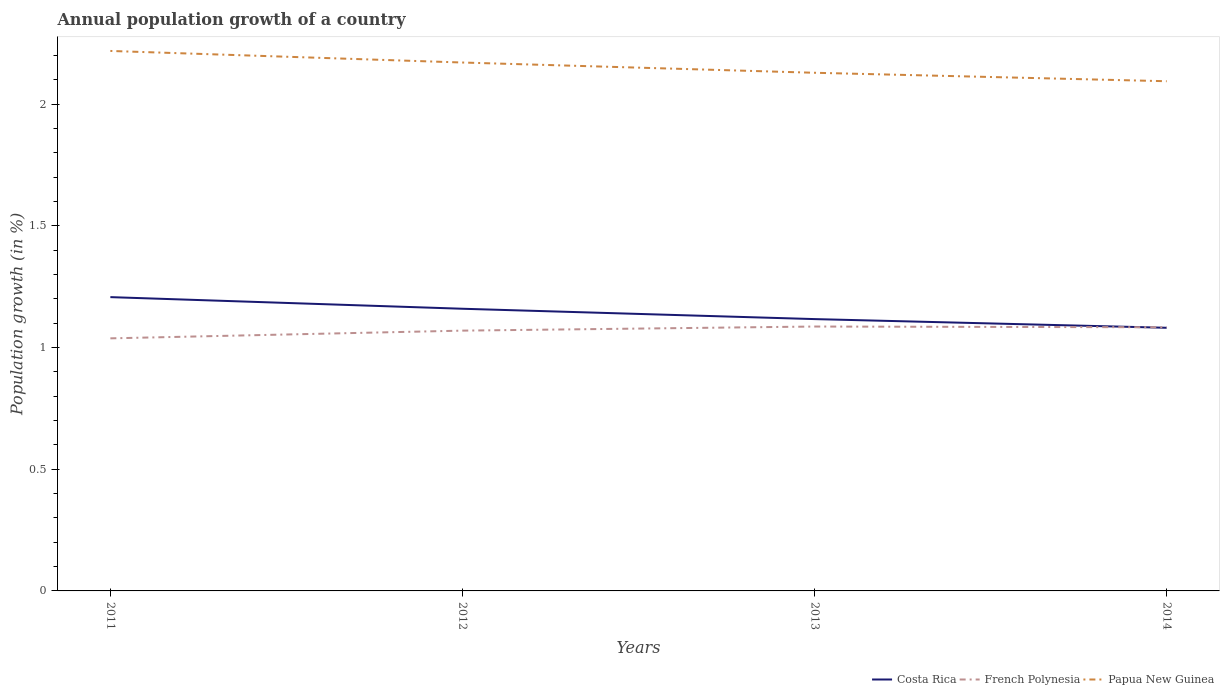Does the line corresponding to French Polynesia intersect with the line corresponding to Costa Rica?
Your answer should be very brief. Yes. Is the number of lines equal to the number of legend labels?
Offer a terse response. Yes. Across all years, what is the maximum annual population growth in Costa Rica?
Provide a short and direct response. 1.08. What is the total annual population growth in Costa Rica in the graph?
Make the answer very short. 0.05. What is the difference between the highest and the second highest annual population growth in Costa Rica?
Your answer should be very brief. 0.13. Is the annual population growth in Costa Rica strictly greater than the annual population growth in French Polynesia over the years?
Offer a terse response. No. How many years are there in the graph?
Your answer should be very brief. 4. Are the values on the major ticks of Y-axis written in scientific E-notation?
Your response must be concise. No. Does the graph contain grids?
Keep it short and to the point. No. Where does the legend appear in the graph?
Give a very brief answer. Bottom right. What is the title of the graph?
Offer a terse response. Annual population growth of a country. What is the label or title of the Y-axis?
Offer a terse response. Population growth (in %). What is the Population growth (in %) of Costa Rica in 2011?
Give a very brief answer. 1.21. What is the Population growth (in %) of French Polynesia in 2011?
Your answer should be very brief. 1.04. What is the Population growth (in %) in Papua New Guinea in 2011?
Offer a very short reply. 2.22. What is the Population growth (in %) of Costa Rica in 2012?
Provide a short and direct response. 1.16. What is the Population growth (in %) of French Polynesia in 2012?
Your answer should be compact. 1.07. What is the Population growth (in %) in Papua New Guinea in 2012?
Your response must be concise. 2.17. What is the Population growth (in %) in Costa Rica in 2013?
Your answer should be compact. 1.12. What is the Population growth (in %) of French Polynesia in 2013?
Ensure brevity in your answer.  1.09. What is the Population growth (in %) in Papua New Guinea in 2013?
Your answer should be very brief. 2.13. What is the Population growth (in %) in Costa Rica in 2014?
Your response must be concise. 1.08. What is the Population growth (in %) in French Polynesia in 2014?
Your response must be concise. 1.08. What is the Population growth (in %) of Papua New Guinea in 2014?
Provide a short and direct response. 2.09. Across all years, what is the maximum Population growth (in %) in Costa Rica?
Offer a terse response. 1.21. Across all years, what is the maximum Population growth (in %) in French Polynesia?
Your answer should be compact. 1.09. Across all years, what is the maximum Population growth (in %) of Papua New Guinea?
Your response must be concise. 2.22. Across all years, what is the minimum Population growth (in %) in Costa Rica?
Offer a very short reply. 1.08. Across all years, what is the minimum Population growth (in %) of French Polynesia?
Offer a very short reply. 1.04. Across all years, what is the minimum Population growth (in %) in Papua New Guinea?
Your response must be concise. 2.09. What is the total Population growth (in %) in Costa Rica in the graph?
Your response must be concise. 4.57. What is the total Population growth (in %) of French Polynesia in the graph?
Provide a short and direct response. 4.28. What is the total Population growth (in %) of Papua New Guinea in the graph?
Offer a terse response. 8.61. What is the difference between the Population growth (in %) of Costa Rica in 2011 and that in 2012?
Provide a short and direct response. 0.05. What is the difference between the Population growth (in %) in French Polynesia in 2011 and that in 2012?
Your answer should be compact. -0.03. What is the difference between the Population growth (in %) of Papua New Guinea in 2011 and that in 2012?
Give a very brief answer. 0.05. What is the difference between the Population growth (in %) of Costa Rica in 2011 and that in 2013?
Provide a succinct answer. 0.09. What is the difference between the Population growth (in %) in French Polynesia in 2011 and that in 2013?
Provide a succinct answer. -0.05. What is the difference between the Population growth (in %) in Papua New Guinea in 2011 and that in 2013?
Provide a succinct answer. 0.09. What is the difference between the Population growth (in %) of Costa Rica in 2011 and that in 2014?
Your response must be concise. 0.13. What is the difference between the Population growth (in %) of French Polynesia in 2011 and that in 2014?
Your answer should be very brief. -0.05. What is the difference between the Population growth (in %) in Papua New Guinea in 2011 and that in 2014?
Your answer should be compact. 0.12. What is the difference between the Population growth (in %) of Costa Rica in 2012 and that in 2013?
Offer a terse response. 0.04. What is the difference between the Population growth (in %) in French Polynesia in 2012 and that in 2013?
Your response must be concise. -0.02. What is the difference between the Population growth (in %) in Papua New Guinea in 2012 and that in 2013?
Ensure brevity in your answer.  0.04. What is the difference between the Population growth (in %) of Costa Rica in 2012 and that in 2014?
Your answer should be compact. 0.08. What is the difference between the Population growth (in %) in French Polynesia in 2012 and that in 2014?
Make the answer very short. -0.01. What is the difference between the Population growth (in %) in Papua New Guinea in 2012 and that in 2014?
Provide a succinct answer. 0.08. What is the difference between the Population growth (in %) of Costa Rica in 2013 and that in 2014?
Your answer should be compact. 0.04. What is the difference between the Population growth (in %) of French Polynesia in 2013 and that in 2014?
Your answer should be compact. 0. What is the difference between the Population growth (in %) of Papua New Guinea in 2013 and that in 2014?
Make the answer very short. 0.03. What is the difference between the Population growth (in %) of Costa Rica in 2011 and the Population growth (in %) of French Polynesia in 2012?
Give a very brief answer. 0.14. What is the difference between the Population growth (in %) in Costa Rica in 2011 and the Population growth (in %) in Papua New Guinea in 2012?
Your answer should be very brief. -0.96. What is the difference between the Population growth (in %) of French Polynesia in 2011 and the Population growth (in %) of Papua New Guinea in 2012?
Your response must be concise. -1.13. What is the difference between the Population growth (in %) in Costa Rica in 2011 and the Population growth (in %) in French Polynesia in 2013?
Offer a very short reply. 0.12. What is the difference between the Population growth (in %) of Costa Rica in 2011 and the Population growth (in %) of Papua New Guinea in 2013?
Your response must be concise. -0.92. What is the difference between the Population growth (in %) of French Polynesia in 2011 and the Population growth (in %) of Papua New Guinea in 2013?
Ensure brevity in your answer.  -1.09. What is the difference between the Population growth (in %) of Costa Rica in 2011 and the Population growth (in %) of French Polynesia in 2014?
Offer a terse response. 0.12. What is the difference between the Population growth (in %) in Costa Rica in 2011 and the Population growth (in %) in Papua New Guinea in 2014?
Your answer should be very brief. -0.89. What is the difference between the Population growth (in %) of French Polynesia in 2011 and the Population growth (in %) of Papua New Guinea in 2014?
Your answer should be very brief. -1.06. What is the difference between the Population growth (in %) in Costa Rica in 2012 and the Population growth (in %) in French Polynesia in 2013?
Your answer should be very brief. 0.07. What is the difference between the Population growth (in %) of Costa Rica in 2012 and the Population growth (in %) of Papua New Guinea in 2013?
Your response must be concise. -0.97. What is the difference between the Population growth (in %) of French Polynesia in 2012 and the Population growth (in %) of Papua New Guinea in 2013?
Provide a succinct answer. -1.06. What is the difference between the Population growth (in %) in Costa Rica in 2012 and the Population growth (in %) in French Polynesia in 2014?
Provide a short and direct response. 0.08. What is the difference between the Population growth (in %) of Costa Rica in 2012 and the Population growth (in %) of Papua New Guinea in 2014?
Keep it short and to the point. -0.94. What is the difference between the Population growth (in %) of French Polynesia in 2012 and the Population growth (in %) of Papua New Guinea in 2014?
Your answer should be compact. -1.02. What is the difference between the Population growth (in %) of Costa Rica in 2013 and the Population growth (in %) of French Polynesia in 2014?
Your answer should be very brief. 0.03. What is the difference between the Population growth (in %) of Costa Rica in 2013 and the Population growth (in %) of Papua New Guinea in 2014?
Your answer should be compact. -0.98. What is the difference between the Population growth (in %) in French Polynesia in 2013 and the Population growth (in %) in Papua New Guinea in 2014?
Give a very brief answer. -1.01. What is the average Population growth (in %) in Costa Rica per year?
Give a very brief answer. 1.14. What is the average Population growth (in %) of French Polynesia per year?
Offer a very short reply. 1.07. What is the average Population growth (in %) in Papua New Guinea per year?
Your answer should be compact. 2.15. In the year 2011, what is the difference between the Population growth (in %) in Costa Rica and Population growth (in %) in French Polynesia?
Make the answer very short. 0.17. In the year 2011, what is the difference between the Population growth (in %) in Costa Rica and Population growth (in %) in Papua New Guinea?
Give a very brief answer. -1.01. In the year 2011, what is the difference between the Population growth (in %) of French Polynesia and Population growth (in %) of Papua New Guinea?
Offer a terse response. -1.18. In the year 2012, what is the difference between the Population growth (in %) in Costa Rica and Population growth (in %) in French Polynesia?
Offer a terse response. 0.09. In the year 2012, what is the difference between the Population growth (in %) in Costa Rica and Population growth (in %) in Papua New Guinea?
Provide a short and direct response. -1.01. In the year 2012, what is the difference between the Population growth (in %) in French Polynesia and Population growth (in %) in Papua New Guinea?
Your response must be concise. -1.1. In the year 2013, what is the difference between the Population growth (in %) in Costa Rica and Population growth (in %) in French Polynesia?
Keep it short and to the point. 0.03. In the year 2013, what is the difference between the Population growth (in %) in Costa Rica and Population growth (in %) in Papua New Guinea?
Provide a short and direct response. -1.01. In the year 2013, what is the difference between the Population growth (in %) of French Polynesia and Population growth (in %) of Papua New Guinea?
Provide a succinct answer. -1.04. In the year 2014, what is the difference between the Population growth (in %) in Costa Rica and Population growth (in %) in French Polynesia?
Ensure brevity in your answer.  -0. In the year 2014, what is the difference between the Population growth (in %) of Costa Rica and Population growth (in %) of Papua New Guinea?
Offer a very short reply. -1.01. In the year 2014, what is the difference between the Population growth (in %) in French Polynesia and Population growth (in %) in Papua New Guinea?
Your response must be concise. -1.01. What is the ratio of the Population growth (in %) of Costa Rica in 2011 to that in 2012?
Ensure brevity in your answer.  1.04. What is the ratio of the Population growth (in %) of French Polynesia in 2011 to that in 2012?
Your response must be concise. 0.97. What is the ratio of the Population growth (in %) in Papua New Guinea in 2011 to that in 2012?
Ensure brevity in your answer.  1.02. What is the ratio of the Population growth (in %) in Costa Rica in 2011 to that in 2013?
Your response must be concise. 1.08. What is the ratio of the Population growth (in %) of French Polynesia in 2011 to that in 2013?
Your answer should be compact. 0.96. What is the ratio of the Population growth (in %) in Papua New Guinea in 2011 to that in 2013?
Your answer should be compact. 1.04. What is the ratio of the Population growth (in %) of Costa Rica in 2011 to that in 2014?
Your answer should be compact. 1.12. What is the ratio of the Population growth (in %) of French Polynesia in 2011 to that in 2014?
Offer a very short reply. 0.96. What is the ratio of the Population growth (in %) in Papua New Guinea in 2011 to that in 2014?
Your answer should be compact. 1.06. What is the ratio of the Population growth (in %) of Costa Rica in 2012 to that in 2013?
Give a very brief answer. 1.04. What is the ratio of the Population growth (in %) of French Polynesia in 2012 to that in 2013?
Your answer should be very brief. 0.98. What is the ratio of the Population growth (in %) of Papua New Guinea in 2012 to that in 2013?
Ensure brevity in your answer.  1.02. What is the ratio of the Population growth (in %) in Costa Rica in 2012 to that in 2014?
Your answer should be very brief. 1.07. What is the ratio of the Population growth (in %) of French Polynesia in 2012 to that in 2014?
Offer a terse response. 0.99. What is the ratio of the Population growth (in %) of Papua New Guinea in 2012 to that in 2014?
Provide a succinct answer. 1.04. What is the ratio of the Population growth (in %) of Costa Rica in 2013 to that in 2014?
Ensure brevity in your answer.  1.03. What is the ratio of the Population growth (in %) in Papua New Guinea in 2013 to that in 2014?
Make the answer very short. 1.02. What is the difference between the highest and the second highest Population growth (in %) of Costa Rica?
Keep it short and to the point. 0.05. What is the difference between the highest and the second highest Population growth (in %) in French Polynesia?
Provide a succinct answer. 0. What is the difference between the highest and the second highest Population growth (in %) of Papua New Guinea?
Keep it short and to the point. 0.05. What is the difference between the highest and the lowest Population growth (in %) in Costa Rica?
Keep it short and to the point. 0.13. What is the difference between the highest and the lowest Population growth (in %) of French Polynesia?
Give a very brief answer. 0.05. What is the difference between the highest and the lowest Population growth (in %) of Papua New Guinea?
Offer a very short reply. 0.12. 